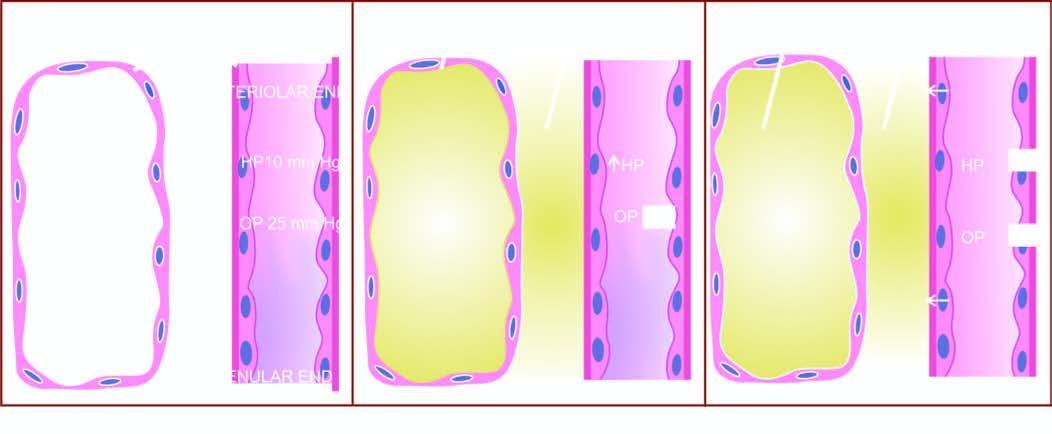s c, x-ray crystallography and infra-red spectroscopy involved in the pathogenesis of cardiac oedema?
Answer the question using a single word or phrase. No 